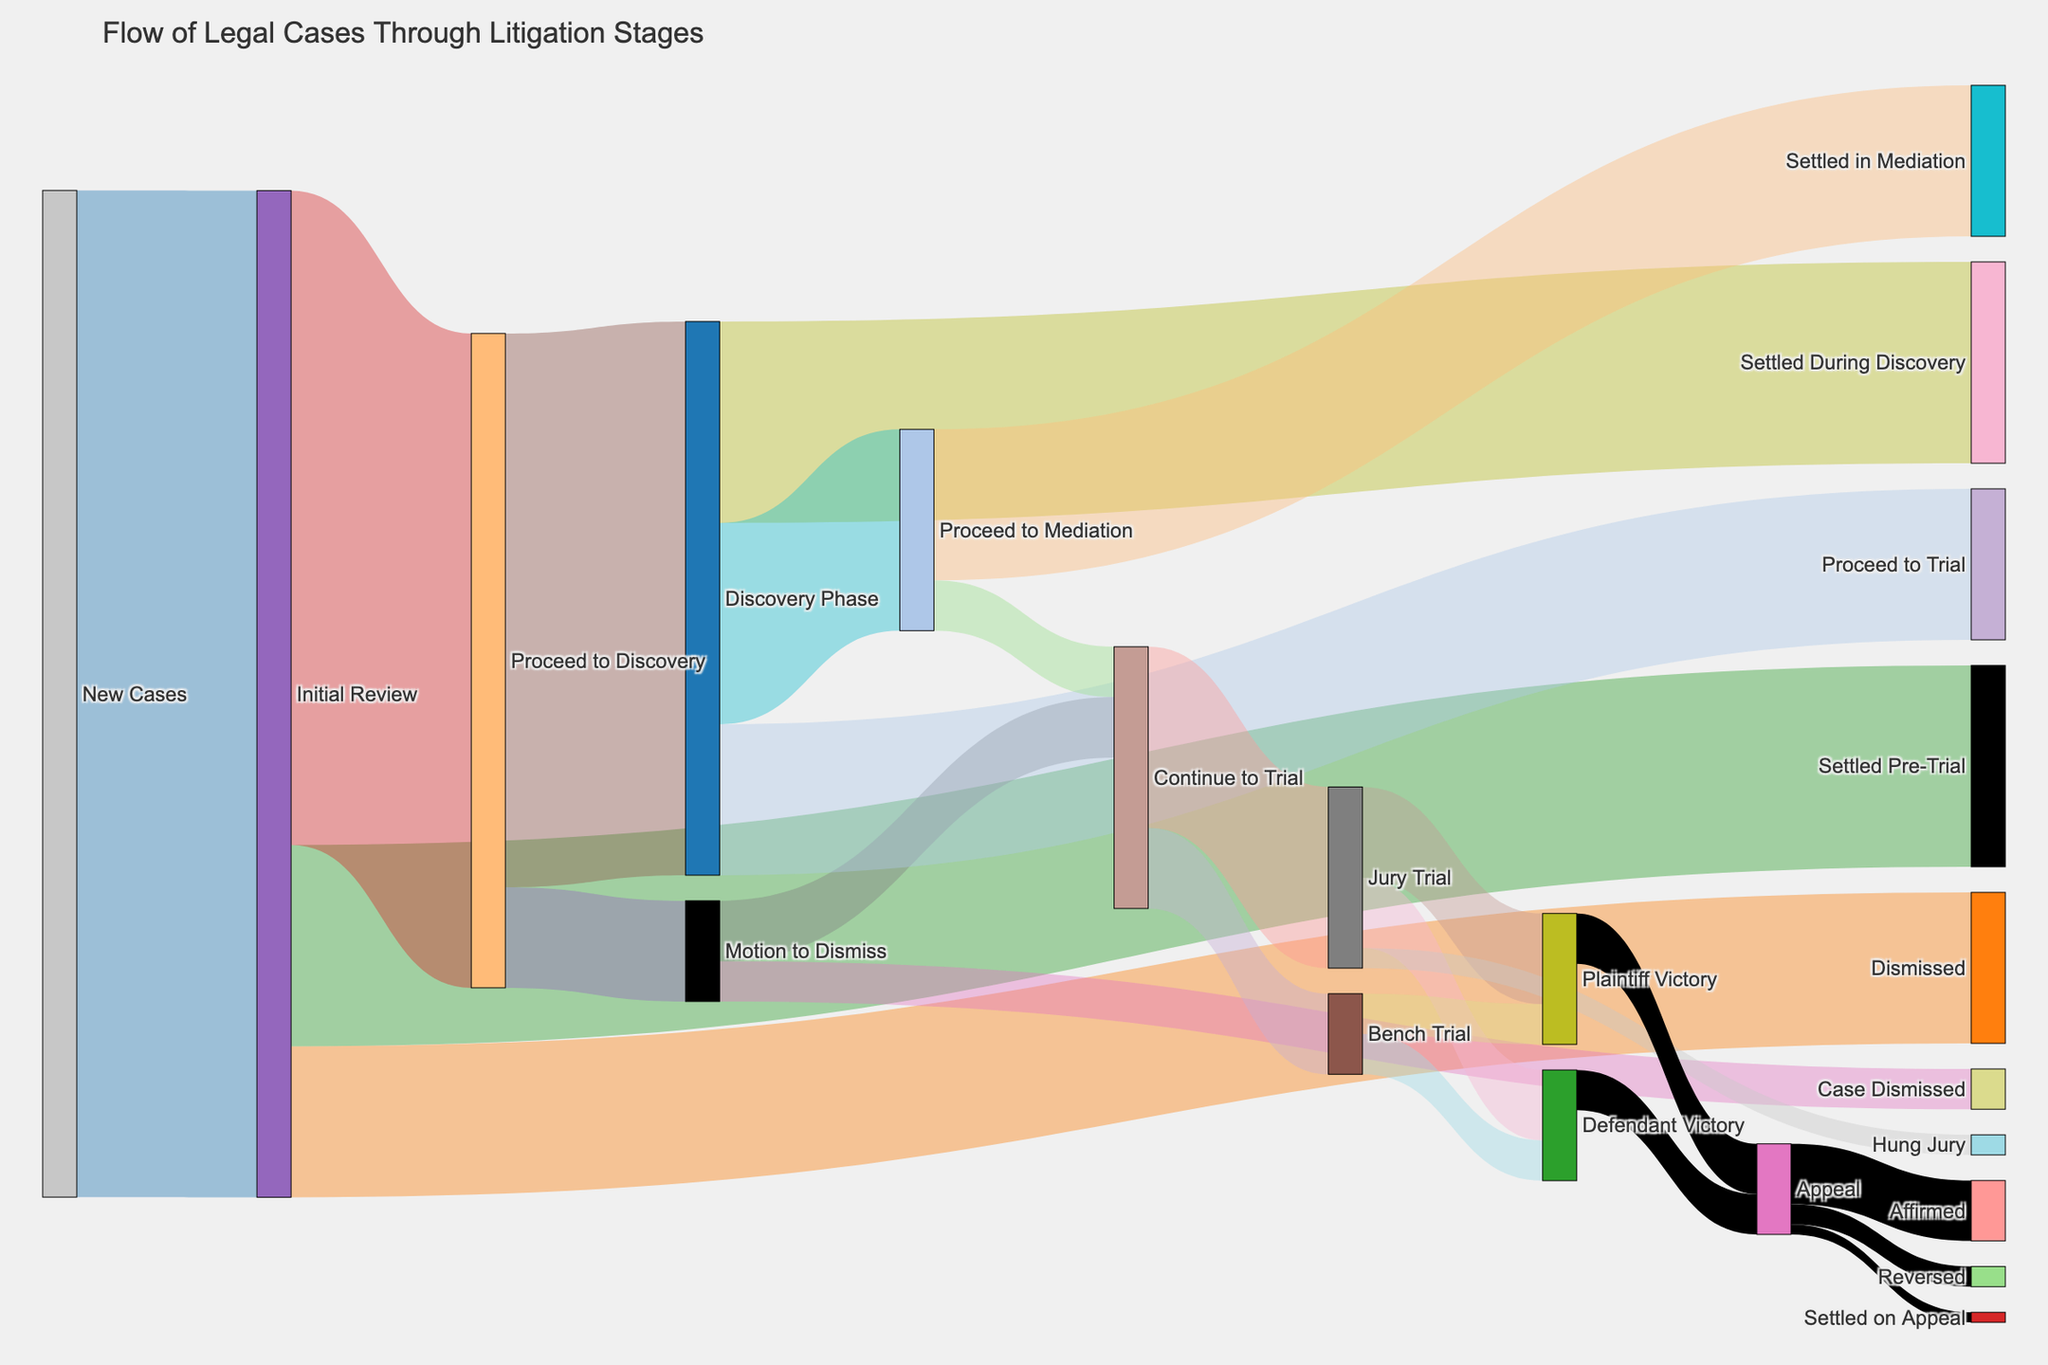What is the total number of new cases? Look at the flow from "New Cases" to "Initial Review" in the diagram. The value associated with this flow is 1000, indicating the total number of new cases.
Answer: 1000 How many cases were dismissed at the initial review stage? Find the flow from "Initial Review" to "Dismissed" in the diagram. The value associated with this flow is 150, indicating the number of cases dismissed at the initial review stage.
Answer: 150 How many cases proceeded to the discovery phase after the initial review? Identify the flow from "Initial Review" to "Proceed to Discovery" in the diagram. The value associated with this flow is 650, indicating the number of cases that proceeded to discovery.
Answer: 650 How many cases were dismissed during the motion to dismiss phase? Locate the flow from "Motion to Dismiss" to "Case Dismissed" in the diagram. The value associated with this flow is 40, indicating the number of cases dismissed during this phase.
Answer: 40 How many cases proceeded from mediation to trial? Check the flow from "Proceed to Mediation" to "Continue to Trial" in the diagram. The value associated with this flow is 50, indicating the number of cases proceeding to trial from mediation.
Answer: 50 What is the total number of cases that resulted in a trial (both jury and bench trial)? To find the total cases that resulted in a trial, add the values for the flows from "Continue to Trial" to "Jury Trial" and "Continue to Trial" to "Bench Trial". These values are 180 and 80, respectively. So, the total is 180 + 80 = 260.
Answer: 260 How many cases were settled during the discovery phase? Look at the flow from "Discovery Phase" to "Settled During Discovery" in the diagram. The value associated with this flow is 200, indicating the number of cases settled during discovery.
Answer: 200 How many cases resulted in a plaintiff victory across both jury and bench trials? Add the values for flows from "Jury Trial" to "Plaintiff Victory" and "Bench Trial" to "Plaintiff Victory". These values are 90 and 40, respectively. So, the total is 90 + 40 = 130.
Answer: 130 Which stage has the highest number of cases proceeding to the next stage from initial review? Compare the values for all flows from "Initial Review". The flows are to "Dismissed" (150), "Settled Pre-Trial" (200), and "Proceed to Discovery" (650). The highest value is 650 for "Proceed to Discovery".
Answer: Proceed to Discovery How many cases were affirmed on appeal? Identify the flow from "Appeal" to "Affirmed" in the diagram. The value associated with this flow is 60, indicating the number of cases affirmed on appeal.
Answer: 60 